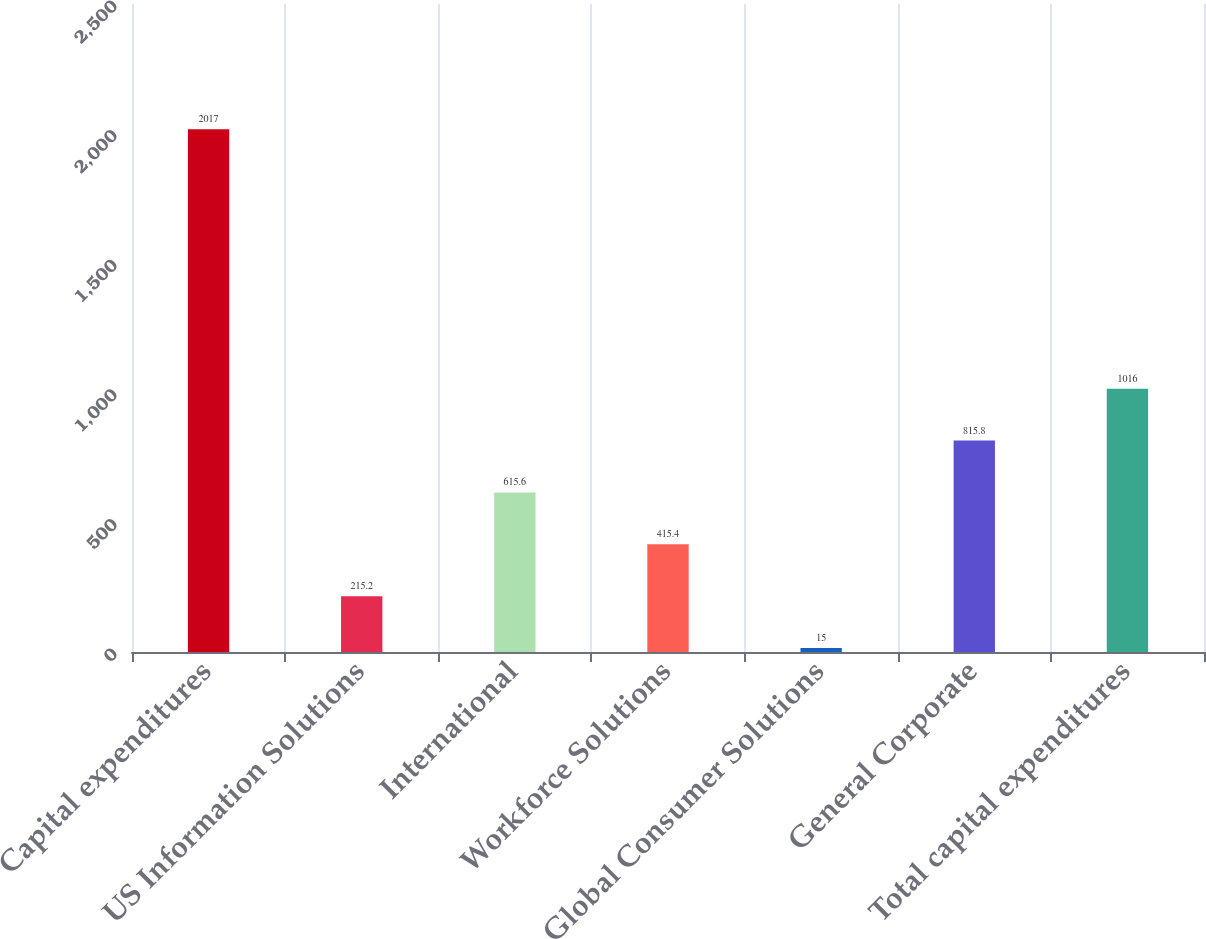<chart> <loc_0><loc_0><loc_500><loc_500><bar_chart><fcel>Capital expenditures<fcel>US Information Solutions<fcel>International<fcel>Workforce Solutions<fcel>Global Consumer Solutions<fcel>General Corporate<fcel>Total capital expenditures<nl><fcel>2017<fcel>215.2<fcel>615.6<fcel>415.4<fcel>15<fcel>815.8<fcel>1016<nl></chart> 